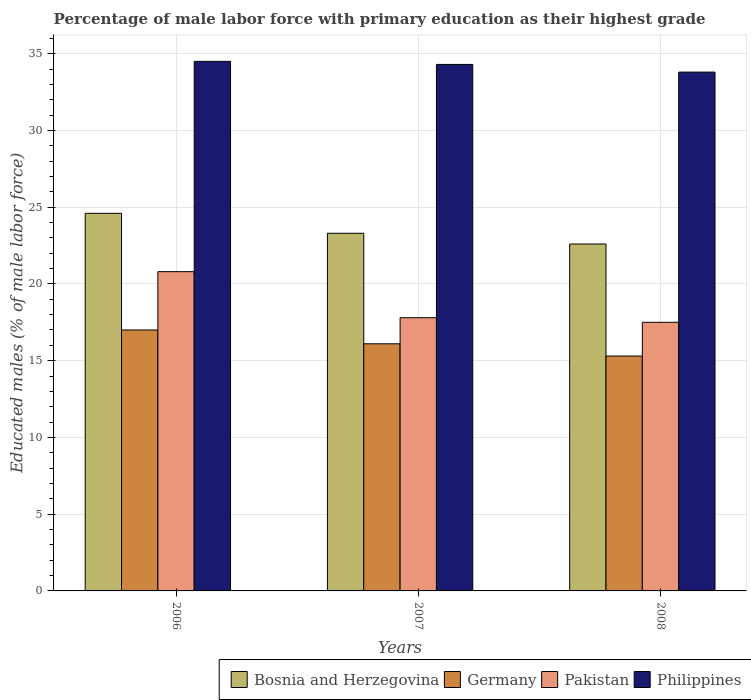How many groups of bars are there?
Offer a terse response. 3. Are the number of bars per tick equal to the number of legend labels?
Make the answer very short. Yes. Are the number of bars on each tick of the X-axis equal?
Give a very brief answer. Yes. How many bars are there on the 2nd tick from the left?
Offer a very short reply. 4. What is the label of the 2nd group of bars from the left?
Keep it short and to the point. 2007. In how many cases, is the number of bars for a given year not equal to the number of legend labels?
Your answer should be compact. 0. What is the percentage of male labor force with primary education in Germany in 2007?
Offer a very short reply. 16.1. Across all years, what is the maximum percentage of male labor force with primary education in Bosnia and Herzegovina?
Make the answer very short. 24.6. Across all years, what is the minimum percentage of male labor force with primary education in Philippines?
Your answer should be compact. 33.8. In which year was the percentage of male labor force with primary education in Philippines maximum?
Provide a succinct answer. 2006. What is the total percentage of male labor force with primary education in Pakistan in the graph?
Your answer should be very brief. 56.1. What is the difference between the percentage of male labor force with primary education in Pakistan in 2006 and that in 2007?
Your response must be concise. 3. What is the difference between the percentage of male labor force with primary education in Bosnia and Herzegovina in 2008 and the percentage of male labor force with primary education in Philippines in 2007?
Your answer should be compact. -11.7. What is the average percentage of male labor force with primary education in Pakistan per year?
Ensure brevity in your answer.  18.7. In the year 2006, what is the difference between the percentage of male labor force with primary education in Germany and percentage of male labor force with primary education in Pakistan?
Keep it short and to the point. -3.8. In how many years, is the percentage of male labor force with primary education in Germany greater than 13 %?
Make the answer very short. 3. What is the ratio of the percentage of male labor force with primary education in Germany in 2006 to that in 2008?
Offer a very short reply. 1.11. What is the difference between the highest and the second highest percentage of male labor force with primary education in Germany?
Provide a short and direct response. 0.9. What is the difference between the highest and the lowest percentage of male labor force with primary education in Pakistan?
Give a very brief answer. 3.3. Is the sum of the percentage of male labor force with primary education in Philippines in 2007 and 2008 greater than the maximum percentage of male labor force with primary education in Bosnia and Herzegovina across all years?
Provide a short and direct response. Yes. Is it the case that in every year, the sum of the percentage of male labor force with primary education in Pakistan and percentage of male labor force with primary education in Philippines is greater than the sum of percentage of male labor force with primary education in Germany and percentage of male labor force with primary education in Bosnia and Herzegovina?
Your answer should be compact. Yes. How many years are there in the graph?
Offer a terse response. 3. Are the values on the major ticks of Y-axis written in scientific E-notation?
Provide a short and direct response. No. Does the graph contain grids?
Ensure brevity in your answer.  Yes. Where does the legend appear in the graph?
Offer a very short reply. Bottom right. How are the legend labels stacked?
Your answer should be very brief. Horizontal. What is the title of the graph?
Offer a very short reply. Percentage of male labor force with primary education as their highest grade. What is the label or title of the X-axis?
Give a very brief answer. Years. What is the label or title of the Y-axis?
Offer a very short reply. Educated males (% of male labor force). What is the Educated males (% of male labor force) in Bosnia and Herzegovina in 2006?
Your answer should be very brief. 24.6. What is the Educated males (% of male labor force) in Pakistan in 2006?
Ensure brevity in your answer.  20.8. What is the Educated males (% of male labor force) of Philippines in 2006?
Ensure brevity in your answer.  34.5. What is the Educated males (% of male labor force) of Bosnia and Herzegovina in 2007?
Keep it short and to the point. 23.3. What is the Educated males (% of male labor force) of Germany in 2007?
Offer a terse response. 16.1. What is the Educated males (% of male labor force) of Pakistan in 2007?
Provide a short and direct response. 17.8. What is the Educated males (% of male labor force) in Philippines in 2007?
Your response must be concise. 34.3. What is the Educated males (% of male labor force) in Bosnia and Herzegovina in 2008?
Your answer should be very brief. 22.6. What is the Educated males (% of male labor force) in Germany in 2008?
Your answer should be compact. 15.3. What is the Educated males (% of male labor force) of Pakistan in 2008?
Give a very brief answer. 17.5. What is the Educated males (% of male labor force) in Philippines in 2008?
Make the answer very short. 33.8. Across all years, what is the maximum Educated males (% of male labor force) in Bosnia and Herzegovina?
Provide a short and direct response. 24.6. Across all years, what is the maximum Educated males (% of male labor force) of Pakistan?
Your response must be concise. 20.8. Across all years, what is the maximum Educated males (% of male labor force) of Philippines?
Your answer should be compact. 34.5. Across all years, what is the minimum Educated males (% of male labor force) in Bosnia and Herzegovina?
Your response must be concise. 22.6. Across all years, what is the minimum Educated males (% of male labor force) of Germany?
Your response must be concise. 15.3. Across all years, what is the minimum Educated males (% of male labor force) of Pakistan?
Provide a short and direct response. 17.5. Across all years, what is the minimum Educated males (% of male labor force) of Philippines?
Keep it short and to the point. 33.8. What is the total Educated males (% of male labor force) in Bosnia and Herzegovina in the graph?
Provide a succinct answer. 70.5. What is the total Educated males (% of male labor force) in Germany in the graph?
Keep it short and to the point. 48.4. What is the total Educated males (% of male labor force) of Pakistan in the graph?
Keep it short and to the point. 56.1. What is the total Educated males (% of male labor force) of Philippines in the graph?
Offer a terse response. 102.6. What is the difference between the Educated males (% of male labor force) of Germany in 2006 and that in 2007?
Offer a very short reply. 0.9. What is the difference between the Educated males (% of male labor force) in Bosnia and Herzegovina in 2006 and that in 2008?
Keep it short and to the point. 2. What is the difference between the Educated males (% of male labor force) in Germany in 2007 and that in 2008?
Keep it short and to the point. 0.8. What is the difference between the Educated males (% of male labor force) of Pakistan in 2007 and that in 2008?
Provide a short and direct response. 0.3. What is the difference between the Educated males (% of male labor force) in Bosnia and Herzegovina in 2006 and the Educated males (% of male labor force) in Pakistan in 2007?
Your answer should be very brief. 6.8. What is the difference between the Educated males (% of male labor force) in Bosnia and Herzegovina in 2006 and the Educated males (% of male labor force) in Philippines in 2007?
Offer a very short reply. -9.7. What is the difference between the Educated males (% of male labor force) in Germany in 2006 and the Educated males (% of male labor force) in Pakistan in 2007?
Your response must be concise. -0.8. What is the difference between the Educated males (% of male labor force) in Germany in 2006 and the Educated males (% of male labor force) in Philippines in 2007?
Your answer should be very brief. -17.3. What is the difference between the Educated males (% of male labor force) of Bosnia and Herzegovina in 2006 and the Educated males (% of male labor force) of Germany in 2008?
Your response must be concise. 9.3. What is the difference between the Educated males (% of male labor force) of Bosnia and Herzegovina in 2006 and the Educated males (% of male labor force) of Philippines in 2008?
Provide a succinct answer. -9.2. What is the difference between the Educated males (% of male labor force) in Germany in 2006 and the Educated males (% of male labor force) in Pakistan in 2008?
Your answer should be very brief. -0.5. What is the difference between the Educated males (% of male labor force) of Germany in 2006 and the Educated males (% of male labor force) of Philippines in 2008?
Ensure brevity in your answer.  -16.8. What is the difference between the Educated males (% of male labor force) in Bosnia and Herzegovina in 2007 and the Educated males (% of male labor force) in Pakistan in 2008?
Your answer should be very brief. 5.8. What is the difference between the Educated males (% of male labor force) in Bosnia and Herzegovina in 2007 and the Educated males (% of male labor force) in Philippines in 2008?
Ensure brevity in your answer.  -10.5. What is the difference between the Educated males (% of male labor force) of Germany in 2007 and the Educated males (% of male labor force) of Philippines in 2008?
Provide a succinct answer. -17.7. What is the average Educated males (% of male labor force) of Bosnia and Herzegovina per year?
Offer a very short reply. 23.5. What is the average Educated males (% of male labor force) of Germany per year?
Keep it short and to the point. 16.13. What is the average Educated males (% of male labor force) in Philippines per year?
Provide a short and direct response. 34.2. In the year 2006, what is the difference between the Educated males (% of male labor force) of Bosnia and Herzegovina and Educated males (% of male labor force) of Pakistan?
Provide a succinct answer. 3.8. In the year 2006, what is the difference between the Educated males (% of male labor force) in Bosnia and Herzegovina and Educated males (% of male labor force) in Philippines?
Provide a succinct answer. -9.9. In the year 2006, what is the difference between the Educated males (% of male labor force) in Germany and Educated males (% of male labor force) in Philippines?
Give a very brief answer. -17.5. In the year 2006, what is the difference between the Educated males (% of male labor force) in Pakistan and Educated males (% of male labor force) in Philippines?
Give a very brief answer. -13.7. In the year 2007, what is the difference between the Educated males (% of male labor force) of Bosnia and Herzegovina and Educated males (% of male labor force) of Germany?
Offer a terse response. 7.2. In the year 2007, what is the difference between the Educated males (% of male labor force) of Germany and Educated males (% of male labor force) of Philippines?
Provide a short and direct response. -18.2. In the year 2007, what is the difference between the Educated males (% of male labor force) of Pakistan and Educated males (% of male labor force) of Philippines?
Keep it short and to the point. -16.5. In the year 2008, what is the difference between the Educated males (% of male labor force) of Germany and Educated males (% of male labor force) of Pakistan?
Your answer should be compact. -2.2. In the year 2008, what is the difference between the Educated males (% of male labor force) of Germany and Educated males (% of male labor force) of Philippines?
Your answer should be compact. -18.5. In the year 2008, what is the difference between the Educated males (% of male labor force) in Pakistan and Educated males (% of male labor force) in Philippines?
Your answer should be compact. -16.3. What is the ratio of the Educated males (% of male labor force) of Bosnia and Herzegovina in 2006 to that in 2007?
Give a very brief answer. 1.06. What is the ratio of the Educated males (% of male labor force) of Germany in 2006 to that in 2007?
Your response must be concise. 1.06. What is the ratio of the Educated males (% of male labor force) of Pakistan in 2006 to that in 2007?
Provide a succinct answer. 1.17. What is the ratio of the Educated males (% of male labor force) of Bosnia and Herzegovina in 2006 to that in 2008?
Keep it short and to the point. 1.09. What is the ratio of the Educated males (% of male labor force) in Germany in 2006 to that in 2008?
Your answer should be compact. 1.11. What is the ratio of the Educated males (% of male labor force) of Pakistan in 2006 to that in 2008?
Provide a short and direct response. 1.19. What is the ratio of the Educated males (% of male labor force) in Philippines in 2006 to that in 2008?
Your answer should be very brief. 1.02. What is the ratio of the Educated males (% of male labor force) in Bosnia and Herzegovina in 2007 to that in 2008?
Give a very brief answer. 1.03. What is the ratio of the Educated males (% of male labor force) in Germany in 2007 to that in 2008?
Provide a succinct answer. 1.05. What is the ratio of the Educated males (% of male labor force) in Pakistan in 2007 to that in 2008?
Make the answer very short. 1.02. What is the ratio of the Educated males (% of male labor force) in Philippines in 2007 to that in 2008?
Your answer should be very brief. 1.01. What is the difference between the highest and the second highest Educated males (% of male labor force) in Bosnia and Herzegovina?
Provide a succinct answer. 1.3. What is the difference between the highest and the second highest Educated males (% of male labor force) in Germany?
Provide a succinct answer. 0.9. What is the difference between the highest and the second highest Educated males (% of male labor force) in Pakistan?
Give a very brief answer. 3. What is the difference between the highest and the second highest Educated males (% of male labor force) in Philippines?
Ensure brevity in your answer.  0.2. What is the difference between the highest and the lowest Educated males (% of male labor force) of Germany?
Provide a short and direct response. 1.7. What is the difference between the highest and the lowest Educated males (% of male labor force) of Philippines?
Offer a terse response. 0.7. 